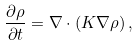<formula> <loc_0><loc_0><loc_500><loc_500>\frac { \partial \rho } { \partial t } = \nabla \cdot ( K \nabla \rho ) \, ,</formula> 